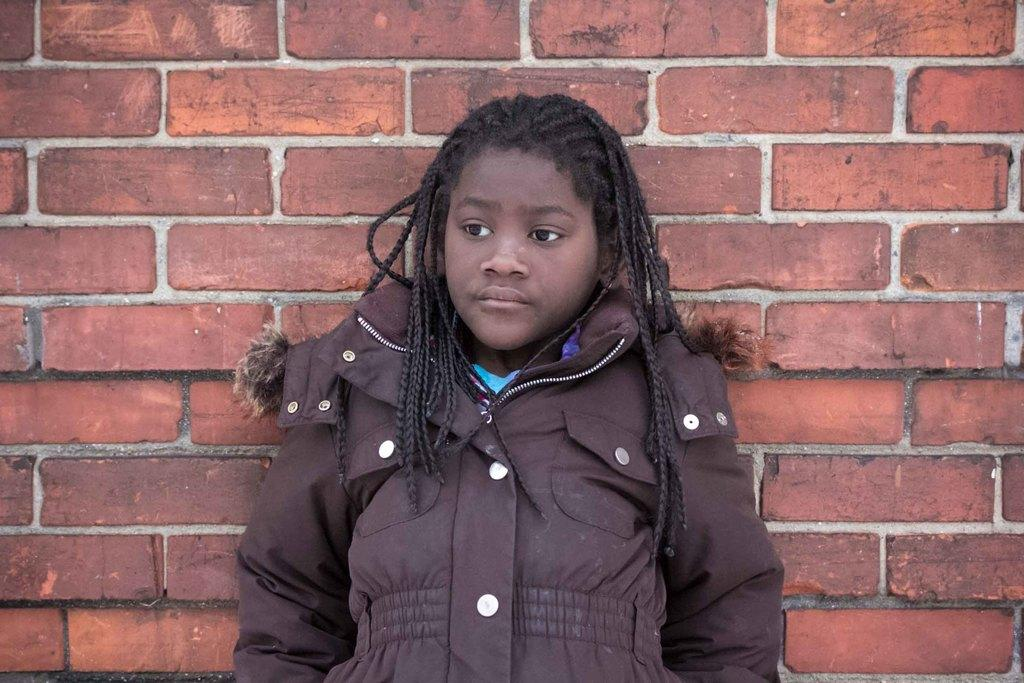What is the main subject of the image? There is a person standing in the image. What can be seen behind the person? There is a wall behind the person. What type of page is being turned by the person in the image? There is no page or indication of reading in the image; the person is simply standing. 